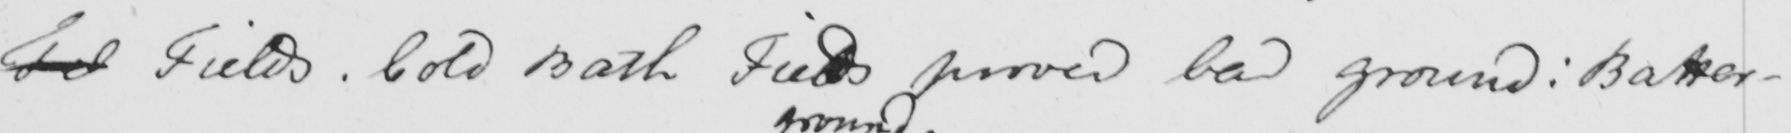Please provide the text content of this handwritten line. Fel Fields . Cold Bath Fields proved bad ground :  Battersea 